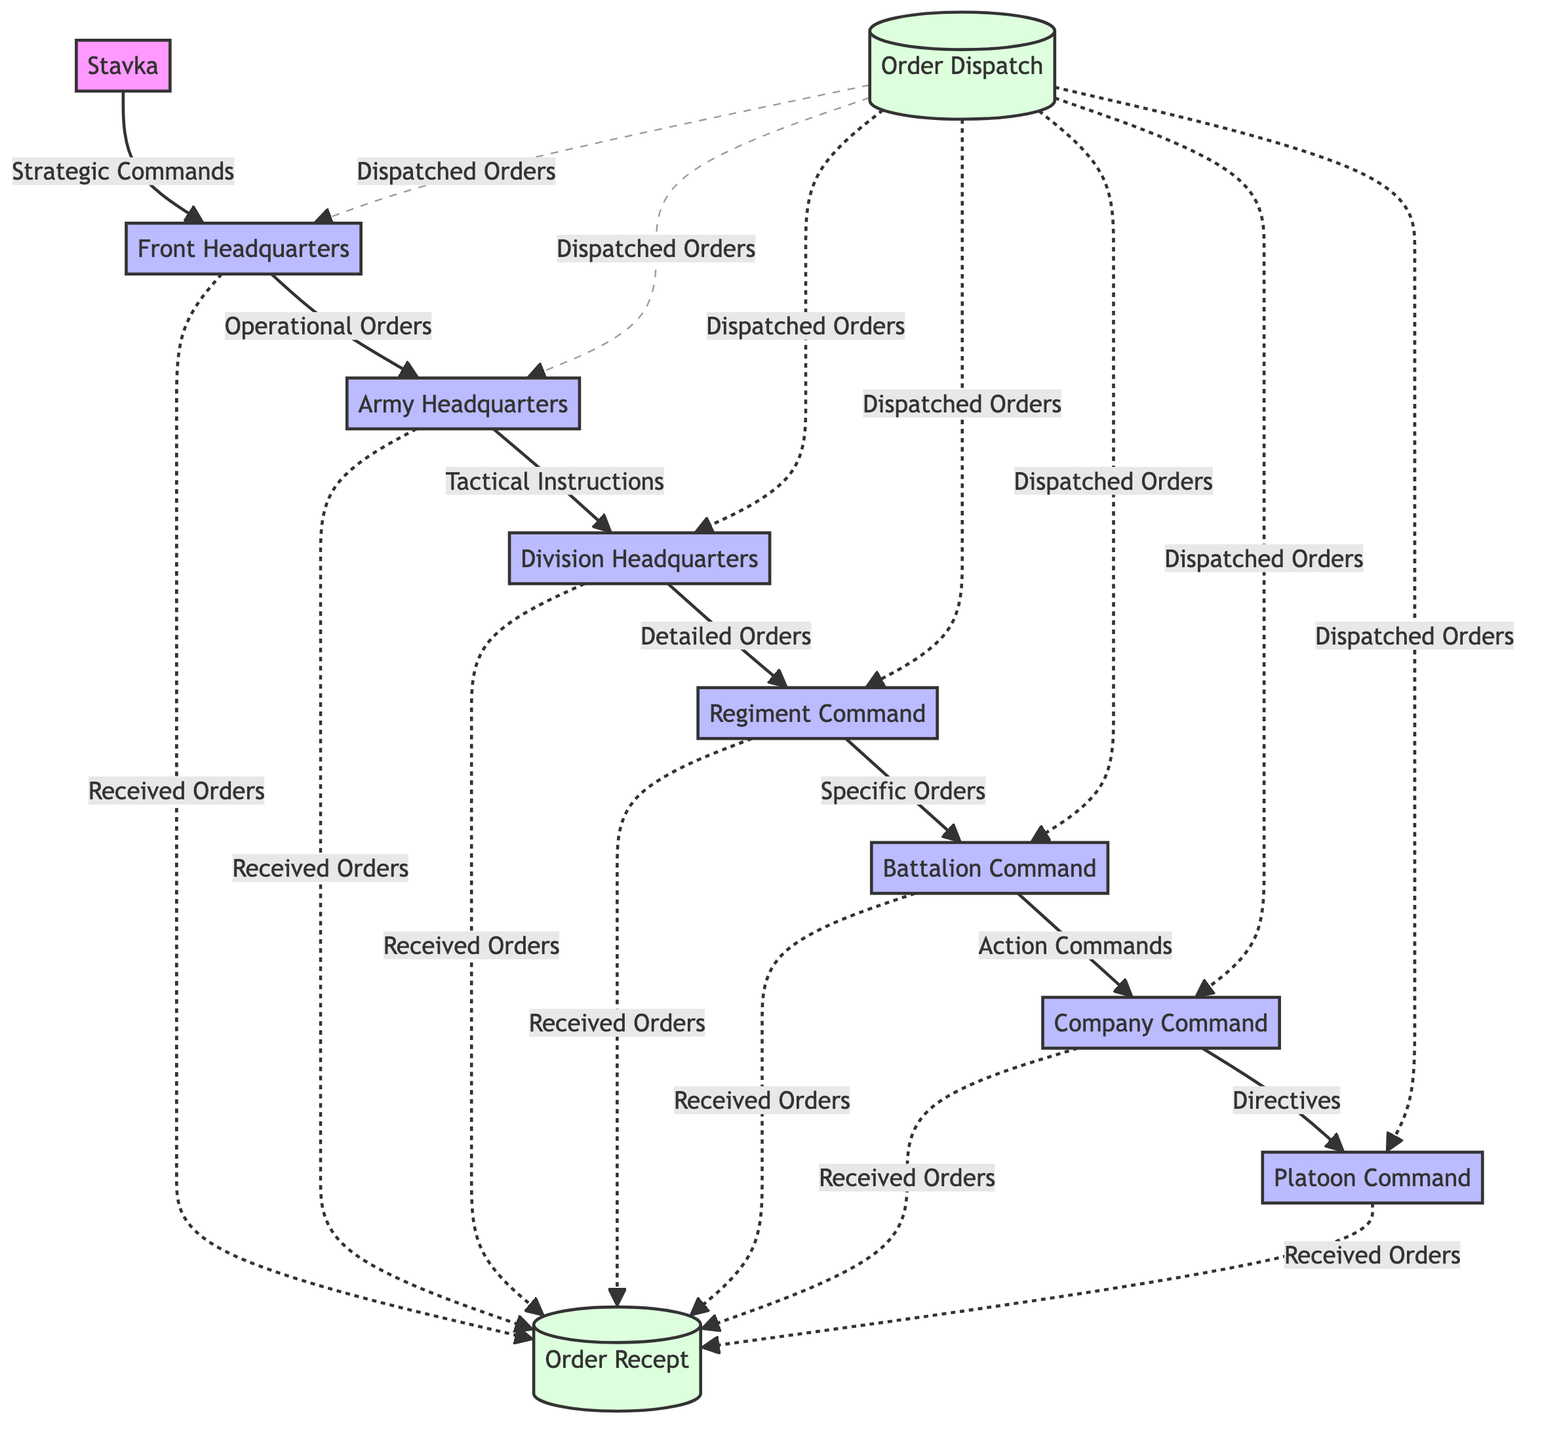What is the first external entity in the diagram? The first external entity in the diagram is Stavka, which serves as the source of strategic commands. This can be seen at the top left of the diagram as the initiating node.
Answer: Stavka How many processing nodes are there in the diagram? There are seven processing nodes: Front Headquarters, Army Headquarters, Division Headquarters, Regiment Command, Battalion Command, Company Command, and Platoon Command. Counting all the process nodes labeled in the diagram confirms this total.
Answer: 7 What type of commands does the Front Headquarters receive from Stavka? The Front Headquarters receives Strategic Commands from Stavka, as indicated by the arrow connecting the two nodes with this specific label.
Answer: Strategic Commands Which node sends Specific Orders to Battalion Command? The node that sends Specific Orders to Battalion Command is Regiment Command. This relationship is represented by a directed arrow connecting the two nodes and labeling the flow as Specific Orders.
Answer: Regiment Command How does the Order Recept receive orders? The Order Recept receives orders through a data flow from various command levels, which includes multiple nodes such as Company Command, Battalion Command, etc., indicating that the order reception is a cumulative process.
Answer: Various Command Levels What type of information is dispatched to various command levels? Dispatched Orders are sent to various command levels, as seen in the dashed arrow originating from Order Dispatch, clearly labeling the information type being sent out.
Answer: Dispatched Orders How many layers of command are there from Stavka to Platoon Command? There are six layers of command, starting from Stavka to Front Headquarters, then to Army Headquarters, Division Headquarters, Regiment Command, Battalion Command, and finally Company Command, before reaching Platoon Command.
Answer: 6 What is the final stage where orders are recorded in the data flow? The final stage where orders are recorded in the data flow is Order Recept, which serves as the endpoint for the orders received from various command levels. This position is noted at the bottom right of the diagram.
Answer: Order Recept Which command receives Tactical Instructions directly from Army Headquarters? The command that receives Tactical Instructions directly from Army Headquarters is Division Headquarters, illustrated by the directed arrow pointing from Army Headquarters to Division Headquarters with the corresponding label.
Answer: Division Headquarters What is indicated by the dashed lines between Order Dispatch and command levels? The dashed lines indicate that dispatched orders are sent to multiple command levels simultaneously, suggesting that this action is not uniquely directed but rather distributed across several processes.
Answer: Dispatched Orders 